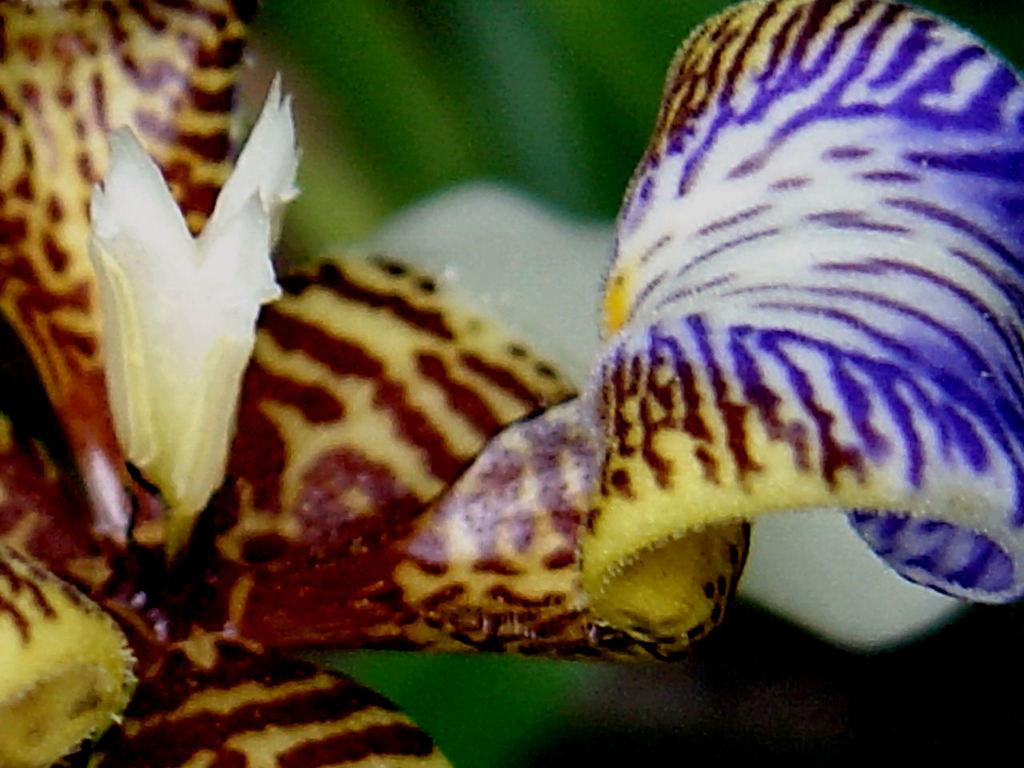What is the main subject of the image? There is a flower in the image. What type of crime is being committed by the flower in the image? There is no crime being committed by the flower in the image, as the flower is a living organism and not capable of committing a crime. 